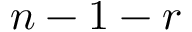Convert formula to latex. <formula><loc_0><loc_0><loc_500><loc_500>n - 1 - r</formula> 